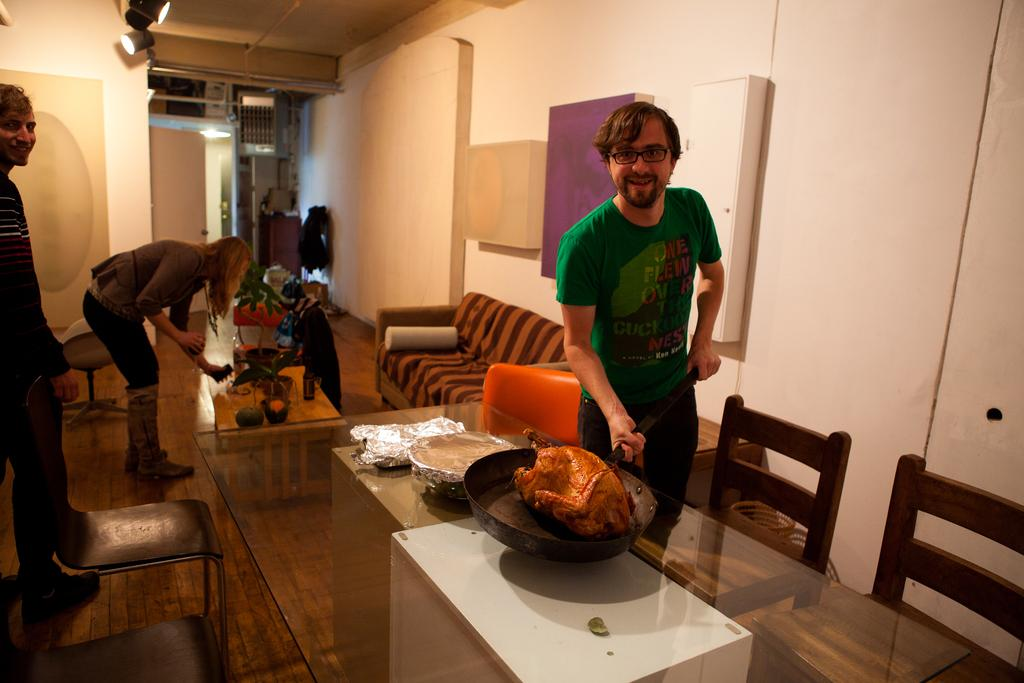Who is the main subject in the image? There is a man in the image. What is the man doing in the image? The man is holding a pan with both hands. Where is the pan located in the image? The pan is on a table. Who else is present in the image? There is a woman in the image, and another person is standing on the left side. Can you describe the woman's position in relation to the man? The woman is behind the man. What type of arch can be seen in the image? There is no arch present in the image. Can you tell me how many rabbits are visible in the image? There are no rabbits present in the image. 